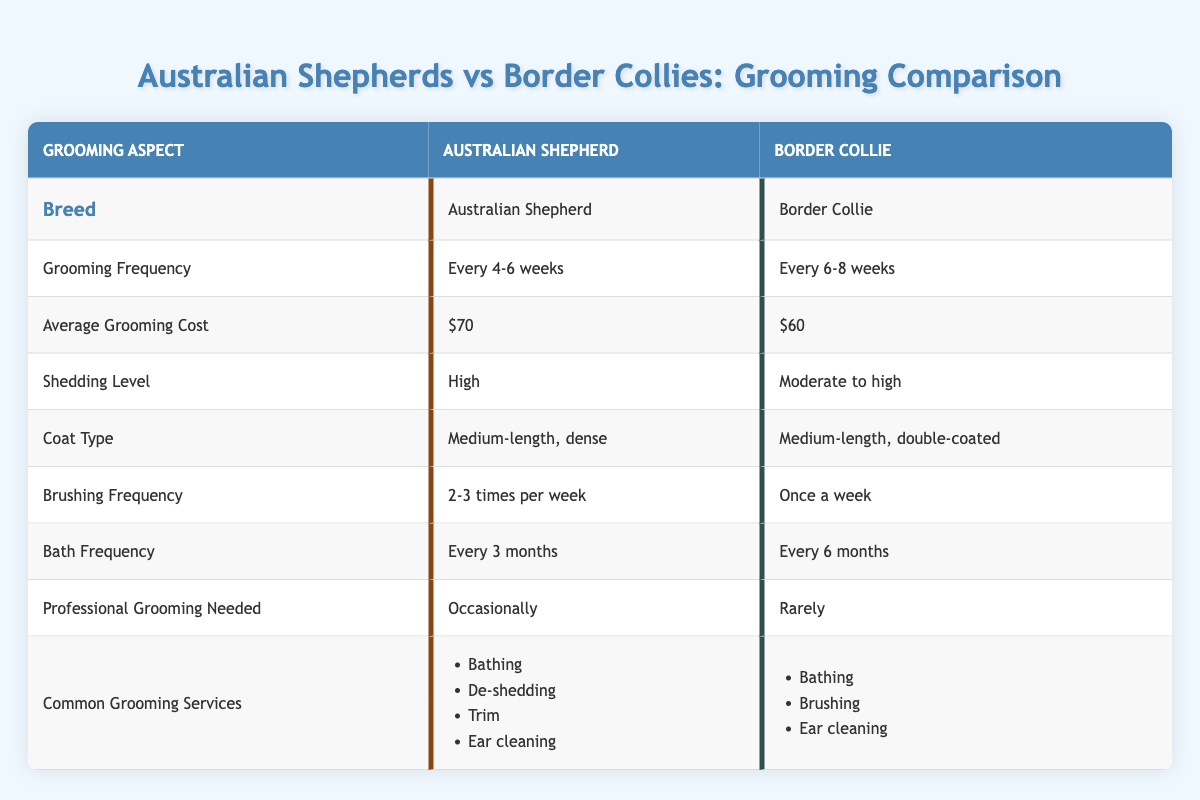What is the average grooming cost for an Australian Shepherd? The table specifies that the average grooming cost for an Australian Shepherd is $70.
Answer: $70 How often do Border Collies need grooming compared to Australian Shepherds? The table states that Border Collies require grooming every 6-8 weeks, while Australian Shepherds need it every 4-6 weeks. This indicates that Australian Shepherds require grooming more frequently.
Answer: More frequently What type of coat does a Border Collie have? According to the table, a Border Collie has a medium-length, double-coated coat type.
Answer: Medium-length, double-coated What is the brushing frequency for Australian Shepherds? The table indicates that Australian Shepherds should be brushed 2-3 times per week.
Answer: 2-3 times per week Is professional grooming required for Border Collies? The data shows that professional grooming for Border Collies is rarely needed.
Answer: No What is the difference in average grooming costs between Australian Shepherds and Border Collies? The average grooming cost for Australian Shepherds is $70 and for Border Collies is $60. The difference is $70 - $60 = $10.
Answer: $10 How often do you need to bathe an Australian Shepherd compared to a Border Collie? Australian Shepherds need to be bathed every 3 months, while Border Collies need bathing every 6 months. This means Australian Shepherds require bathing more often.
Answer: More often Which breed has a higher shedding level? The table indicates that Australian Shepherds have a high shedding level, while Border Collies have a moderate to high shedding level, making Australian Shepherds the breed with the higher shedding level.
Answer: Australian Shepherd What common grooming service is not needed for Border Collies but is for Australian Shepherds? The table lists "De-shedding" as a common grooming service for Australian Shepherds, which is not mentioned for Border Collies.
Answer: De-shedding Considering the frequency of grooming, which breed requires more grooming sessions per year? Australian Shepherds require grooming every 4-6 weeks, leading to approximately 8-12 sessions per year. Border Collies, groomed every 6-8 weeks, need approximately 6-8 sessions per year. Thus, Australian Shepherds require more grooming sessions.
Answer: Australian Shepherds require more sessions 